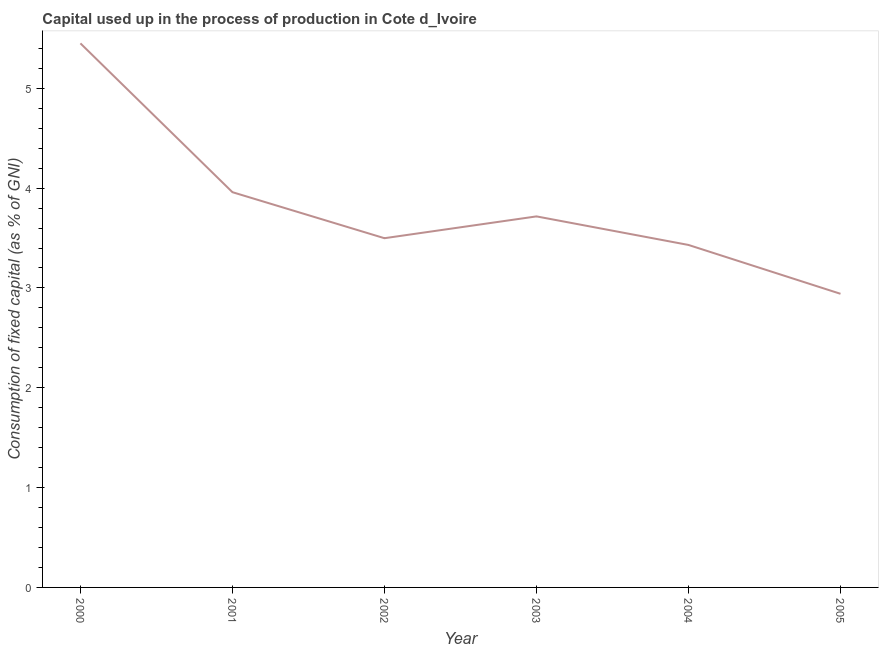What is the consumption of fixed capital in 2000?
Your answer should be compact. 5.45. Across all years, what is the maximum consumption of fixed capital?
Ensure brevity in your answer.  5.45. Across all years, what is the minimum consumption of fixed capital?
Your answer should be compact. 2.94. What is the sum of the consumption of fixed capital?
Make the answer very short. 23. What is the difference between the consumption of fixed capital in 2003 and 2004?
Your answer should be very brief. 0.29. What is the average consumption of fixed capital per year?
Ensure brevity in your answer.  3.83. What is the median consumption of fixed capital?
Keep it short and to the point. 3.61. What is the ratio of the consumption of fixed capital in 2000 to that in 2005?
Offer a terse response. 1.85. Is the consumption of fixed capital in 2000 less than that in 2005?
Your answer should be very brief. No. What is the difference between the highest and the second highest consumption of fixed capital?
Offer a terse response. 1.49. What is the difference between the highest and the lowest consumption of fixed capital?
Offer a terse response. 2.51. How many lines are there?
Give a very brief answer. 1. Are the values on the major ticks of Y-axis written in scientific E-notation?
Provide a succinct answer. No. Does the graph contain any zero values?
Ensure brevity in your answer.  No. Does the graph contain grids?
Offer a very short reply. No. What is the title of the graph?
Make the answer very short. Capital used up in the process of production in Cote d_Ivoire. What is the label or title of the X-axis?
Offer a very short reply. Year. What is the label or title of the Y-axis?
Offer a terse response. Consumption of fixed capital (as % of GNI). What is the Consumption of fixed capital (as % of GNI) of 2000?
Ensure brevity in your answer.  5.45. What is the Consumption of fixed capital (as % of GNI) of 2001?
Provide a succinct answer. 3.96. What is the Consumption of fixed capital (as % of GNI) in 2002?
Keep it short and to the point. 3.5. What is the Consumption of fixed capital (as % of GNI) of 2003?
Your answer should be very brief. 3.72. What is the Consumption of fixed capital (as % of GNI) of 2004?
Your answer should be compact. 3.43. What is the Consumption of fixed capital (as % of GNI) of 2005?
Give a very brief answer. 2.94. What is the difference between the Consumption of fixed capital (as % of GNI) in 2000 and 2001?
Provide a short and direct response. 1.49. What is the difference between the Consumption of fixed capital (as % of GNI) in 2000 and 2002?
Ensure brevity in your answer.  1.95. What is the difference between the Consumption of fixed capital (as % of GNI) in 2000 and 2003?
Offer a terse response. 1.73. What is the difference between the Consumption of fixed capital (as % of GNI) in 2000 and 2004?
Your response must be concise. 2.02. What is the difference between the Consumption of fixed capital (as % of GNI) in 2000 and 2005?
Give a very brief answer. 2.51. What is the difference between the Consumption of fixed capital (as % of GNI) in 2001 and 2002?
Give a very brief answer. 0.46. What is the difference between the Consumption of fixed capital (as % of GNI) in 2001 and 2003?
Keep it short and to the point. 0.24. What is the difference between the Consumption of fixed capital (as % of GNI) in 2001 and 2004?
Ensure brevity in your answer.  0.53. What is the difference between the Consumption of fixed capital (as % of GNI) in 2001 and 2005?
Provide a short and direct response. 1.02. What is the difference between the Consumption of fixed capital (as % of GNI) in 2002 and 2003?
Offer a terse response. -0.22. What is the difference between the Consumption of fixed capital (as % of GNI) in 2002 and 2004?
Your response must be concise. 0.07. What is the difference between the Consumption of fixed capital (as % of GNI) in 2002 and 2005?
Give a very brief answer. 0.56. What is the difference between the Consumption of fixed capital (as % of GNI) in 2003 and 2004?
Ensure brevity in your answer.  0.29. What is the difference between the Consumption of fixed capital (as % of GNI) in 2003 and 2005?
Your answer should be compact. 0.78. What is the difference between the Consumption of fixed capital (as % of GNI) in 2004 and 2005?
Keep it short and to the point. 0.49. What is the ratio of the Consumption of fixed capital (as % of GNI) in 2000 to that in 2001?
Your answer should be compact. 1.38. What is the ratio of the Consumption of fixed capital (as % of GNI) in 2000 to that in 2002?
Ensure brevity in your answer.  1.56. What is the ratio of the Consumption of fixed capital (as % of GNI) in 2000 to that in 2003?
Your answer should be compact. 1.47. What is the ratio of the Consumption of fixed capital (as % of GNI) in 2000 to that in 2004?
Offer a very short reply. 1.59. What is the ratio of the Consumption of fixed capital (as % of GNI) in 2000 to that in 2005?
Your answer should be compact. 1.85. What is the ratio of the Consumption of fixed capital (as % of GNI) in 2001 to that in 2002?
Keep it short and to the point. 1.13. What is the ratio of the Consumption of fixed capital (as % of GNI) in 2001 to that in 2003?
Keep it short and to the point. 1.06. What is the ratio of the Consumption of fixed capital (as % of GNI) in 2001 to that in 2004?
Your response must be concise. 1.15. What is the ratio of the Consumption of fixed capital (as % of GNI) in 2001 to that in 2005?
Offer a terse response. 1.35. What is the ratio of the Consumption of fixed capital (as % of GNI) in 2002 to that in 2003?
Provide a succinct answer. 0.94. What is the ratio of the Consumption of fixed capital (as % of GNI) in 2002 to that in 2004?
Keep it short and to the point. 1.02. What is the ratio of the Consumption of fixed capital (as % of GNI) in 2002 to that in 2005?
Offer a very short reply. 1.19. What is the ratio of the Consumption of fixed capital (as % of GNI) in 2003 to that in 2004?
Provide a short and direct response. 1.08. What is the ratio of the Consumption of fixed capital (as % of GNI) in 2003 to that in 2005?
Give a very brief answer. 1.26. What is the ratio of the Consumption of fixed capital (as % of GNI) in 2004 to that in 2005?
Make the answer very short. 1.17. 